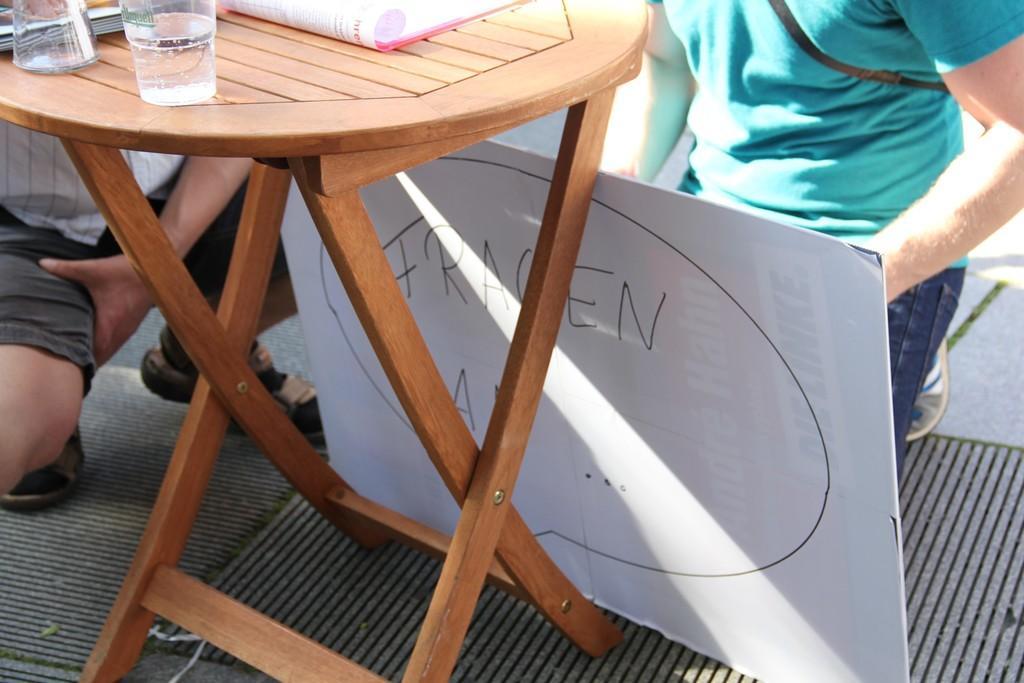Could you give a brief overview of what you see in this image? In this image I can see two glasses and a book on the table and the table is in brown color. Background I can see two persons and a board in white color, and the person at right wearing green shirt, blue pant. 